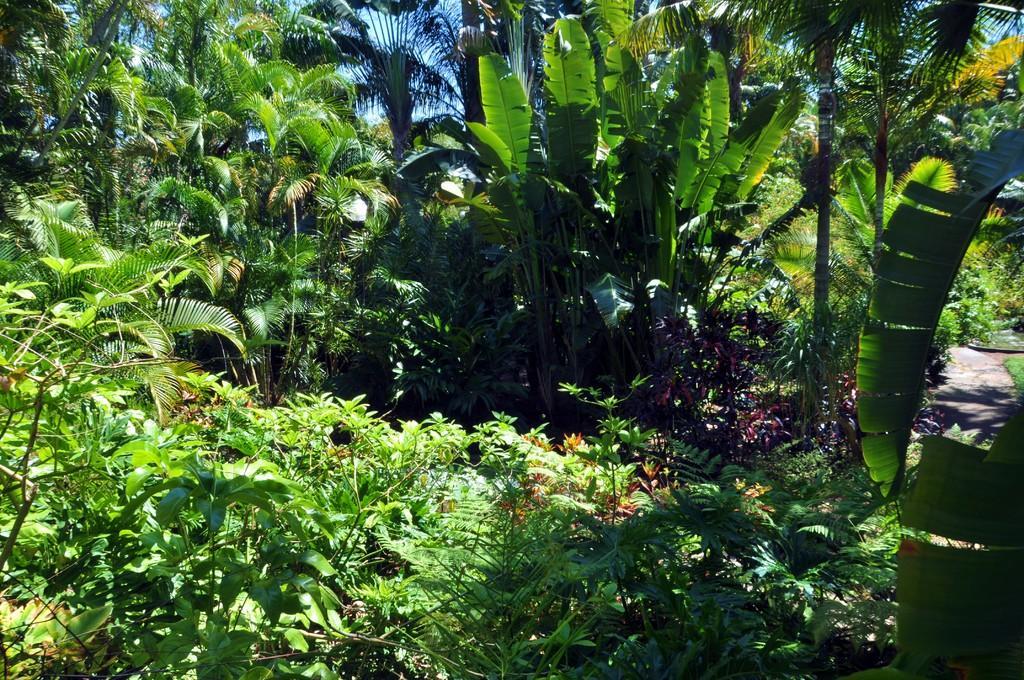In one or two sentences, can you explain what this image depicts? In this image, we can see some plants and trees. We can see the ground and the sky. 